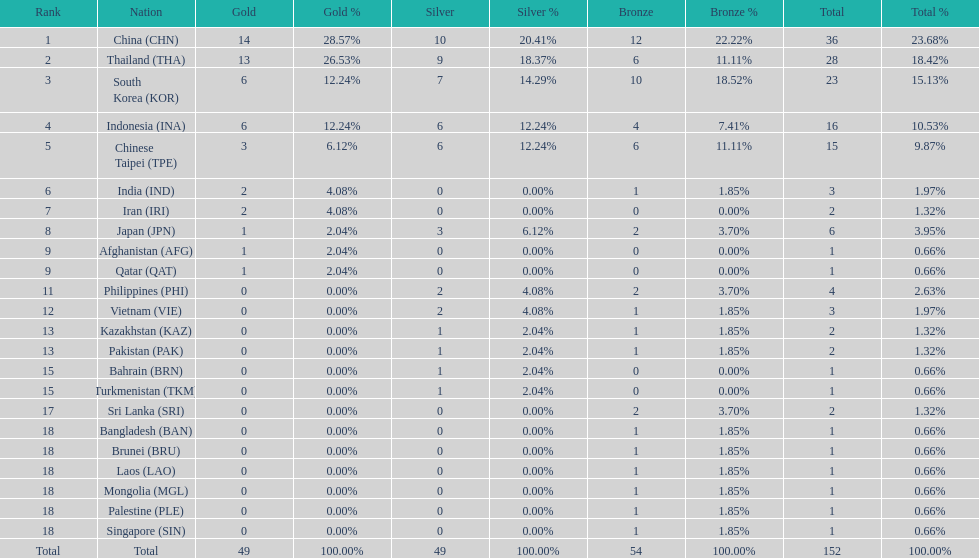Which nations secured the same quantity of gold medals as japan? Afghanistan (AFG), Qatar (QAT). 